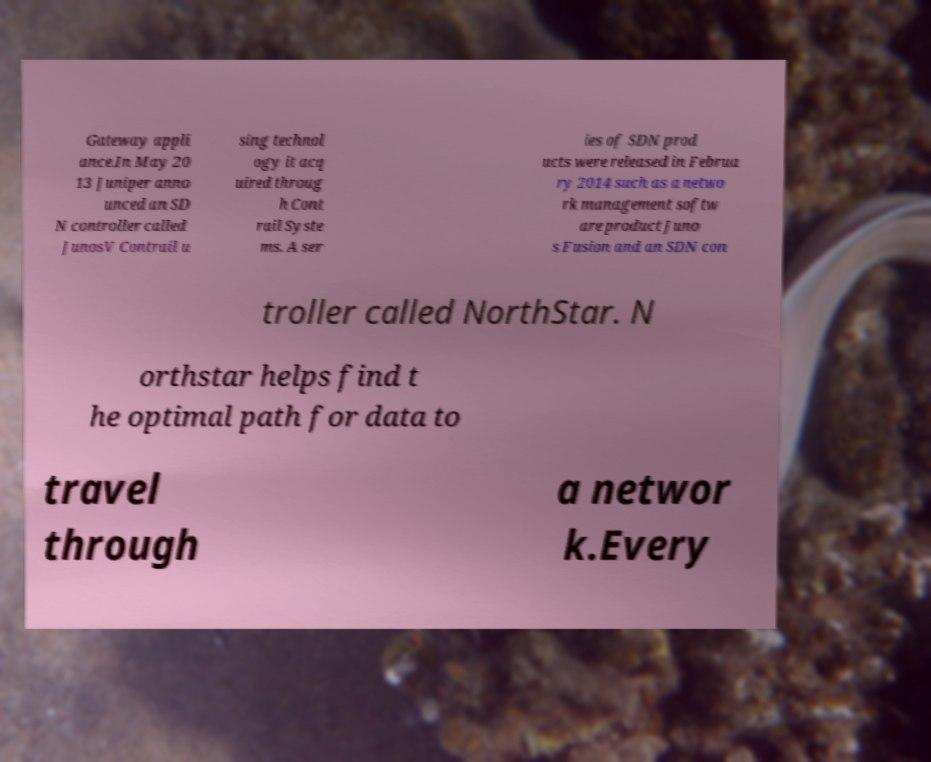Can you read and provide the text displayed in the image?This photo seems to have some interesting text. Can you extract and type it out for me? Gateway appli ance.In May 20 13 Juniper anno unced an SD N controller called JunosV Contrail u sing technol ogy it acq uired throug h Cont rail Syste ms. A ser ies of SDN prod ucts were released in Februa ry 2014 such as a netwo rk management softw are product Juno s Fusion and an SDN con troller called NorthStar. N orthstar helps find t he optimal path for data to travel through a networ k.Every 